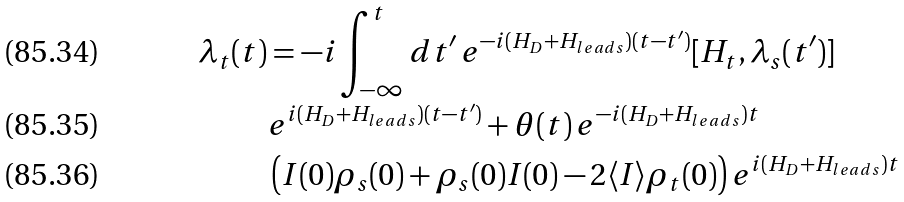Convert formula to latex. <formula><loc_0><loc_0><loc_500><loc_500>\lambda _ { t } ( t ) & = - i \int _ { - \infty } ^ { t } d t ^ { \prime } \, e ^ { - i ( H _ { D } + H _ { l e a d s } ) ( t - t ^ { \prime } ) } [ H _ { t } , \lambda _ { s } ( t ^ { \prime } ) ] \\ & e ^ { i ( H _ { D } + H _ { l e a d s } ) ( t - t ^ { \prime } ) } + \theta ( t ) \, e ^ { - i ( H _ { D } + H _ { l e a d s } ) t } \\ & \left ( I ( 0 ) \rho _ { s } ( 0 ) + \rho _ { s } ( 0 ) I ( 0 ) - 2 \langle I \rangle \rho _ { t } ( 0 ) \right ) e ^ { i ( H _ { D } + H _ { l e a d s } ) t }</formula> 